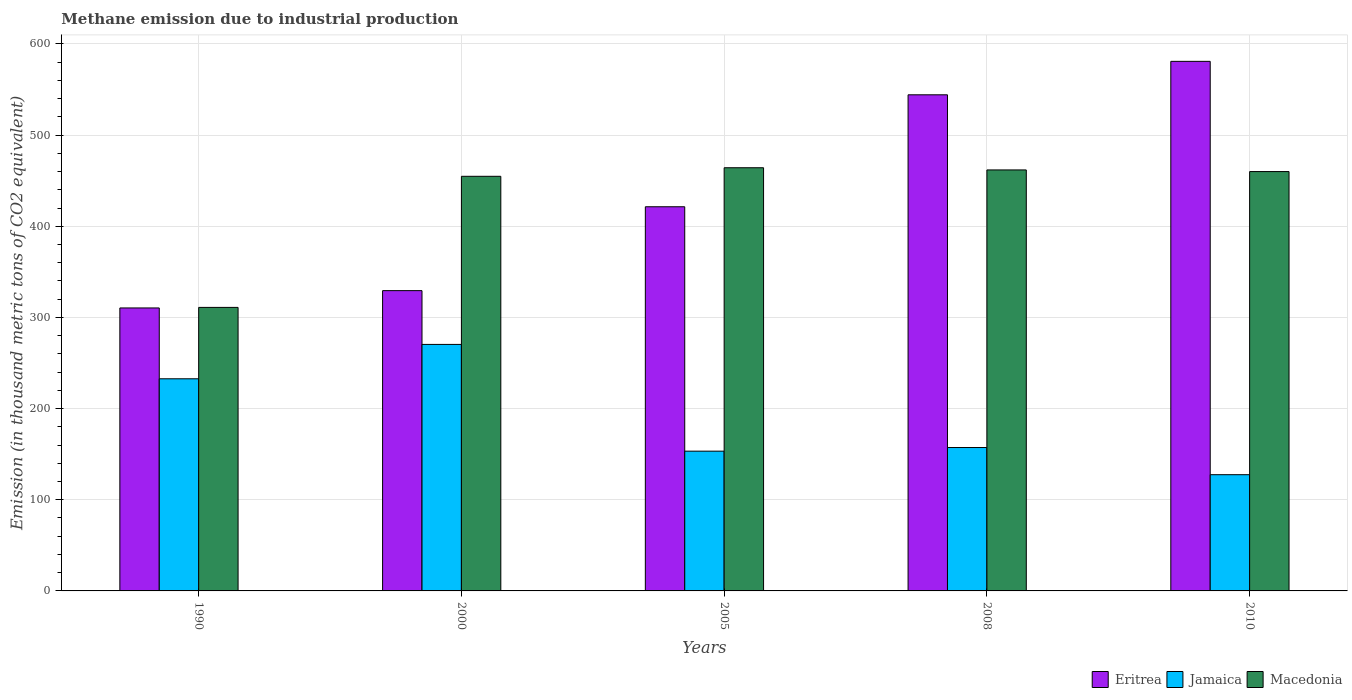How many groups of bars are there?
Provide a short and direct response. 5. Are the number of bars per tick equal to the number of legend labels?
Offer a terse response. Yes. How many bars are there on the 1st tick from the left?
Provide a succinct answer. 3. What is the label of the 4th group of bars from the left?
Ensure brevity in your answer.  2008. What is the amount of methane emitted in Macedonia in 2000?
Your answer should be very brief. 454.8. Across all years, what is the maximum amount of methane emitted in Eritrea?
Offer a very short reply. 580.9. Across all years, what is the minimum amount of methane emitted in Eritrea?
Your response must be concise. 310.4. In which year was the amount of methane emitted in Macedonia maximum?
Your answer should be very brief. 2005. In which year was the amount of methane emitted in Eritrea minimum?
Offer a very short reply. 1990. What is the total amount of methane emitted in Eritrea in the graph?
Offer a very short reply. 2186.3. What is the difference between the amount of methane emitted in Eritrea in 2005 and that in 2010?
Offer a terse response. -159.5. What is the difference between the amount of methane emitted in Eritrea in 2005 and the amount of methane emitted in Macedonia in 1990?
Make the answer very short. 110.4. What is the average amount of methane emitted in Eritrea per year?
Ensure brevity in your answer.  437.26. In the year 2005, what is the difference between the amount of methane emitted in Eritrea and amount of methane emitted in Macedonia?
Your response must be concise. -42.8. In how many years, is the amount of methane emitted in Macedonia greater than 560 thousand metric tons?
Provide a succinct answer. 0. What is the ratio of the amount of methane emitted in Jamaica in 2008 to that in 2010?
Your response must be concise. 1.23. Is the difference between the amount of methane emitted in Eritrea in 2008 and 2010 greater than the difference between the amount of methane emitted in Macedonia in 2008 and 2010?
Keep it short and to the point. No. What is the difference between the highest and the second highest amount of methane emitted in Macedonia?
Ensure brevity in your answer.  2.4. What is the difference between the highest and the lowest amount of methane emitted in Macedonia?
Make the answer very short. 153.2. What does the 2nd bar from the left in 2010 represents?
Offer a very short reply. Jamaica. What does the 1st bar from the right in 2000 represents?
Offer a very short reply. Macedonia. How many bars are there?
Ensure brevity in your answer.  15. Are all the bars in the graph horizontal?
Ensure brevity in your answer.  No. Does the graph contain grids?
Your answer should be very brief. Yes. Where does the legend appear in the graph?
Provide a short and direct response. Bottom right. What is the title of the graph?
Keep it short and to the point. Methane emission due to industrial production. What is the label or title of the Y-axis?
Provide a short and direct response. Emission (in thousand metric tons of CO2 equivalent). What is the Emission (in thousand metric tons of CO2 equivalent) in Eritrea in 1990?
Offer a terse response. 310.4. What is the Emission (in thousand metric tons of CO2 equivalent) in Jamaica in 1990?
Your answer should be compact. 232.7. What is the Emission (in thousand metric tons of CO2 equivalent) of Macedonia in 1990?
Offer a terse response. 311. What is the Emission (in thousand metric tons of CO2 equivalent) in Eritrea in 2000?
Make the answer very short. 329.4. What is the Emission (in thousand metric tons of CO2 equivalent) of Jamaica in 2000?
Give a very brief answer. 270.4. What is the Emission (in thousand metric tons of CO2 equivalent) of Macedonia in 2000?
Provide a succinct answer. 454.8. What is the Emission (in thousand metric tons of CO2 equivalent) of Eritrea in 2005?
Your answer should be very brief. 421.4. What is the Emission (in thousand metric tons of CO2 equivalent) of Jamaica in 2005?
Ensure brevity in your answer.  153.3. What is the Emission (in thousand metric tons of CO2 equivalent) in Macedonia in 2005?
Provide a succinct answer. 464.2. What is the Emission (in thousand metric tons of CO2 equivalent) in Eritrea in 2008?
Your answer should be compact. 544.2. What is the Emission (in thousand metric tons of CO2 equivalent) in Jamaica in 2008?
Ensure brevity in your answer.  157.3. What is the Emission (in thousand metric tons of CO2 equivalent) of Macedonia in 2008?
Your answer should be very brief. 461.8. What is the Emission (in thousand metric tons of CO2 equivalent) of Eritrea in 2010?
Ensure brevity in your answer.  580.9. What is the Emission (in thousand metric tons of CO2 equivalent) of Jamaica in 2010?
Provide a short and direct response. 127.5. What is the Emission (in thousand metric tons of CO2 equivalent) of Macedonia in 2010?
Provide a short and direct response. 460. Across all years, what is the maximum Emission (in thousand metric tons of CO2 equivalent) in Eritrea?
Keep it short and to the point. 580.9. Across all years, what is the maximum Emission (in thousand metric tons of CO2 equivalent) in Jamaica?
Your response must be concise. 270.4. Across all years, what is the maximum Emission (in thousand metric tons of CO2 equivalent) in Macedonia?
Provide a short and direct response. 464.2. Across all years, what is the minimum Emission (in thousand metric tons of CO2 equivalent) of Eritrea?
Your response must be concise. 310.4. Across all years, what is the minimum Emission (in thousand metric tons of CO2 equivalent) of Jamaica?
Offer a terse response. 127.5. Across all years, what is the minimum Emission (in thousand metric tons of CO2 equivalent) in Macedonia?
Your answer should be very brief. 311. What is the total Emission (in thousand metric tons of CO2 equivalent) in Eritrea in the graph?
Give a very brief answer. 2186.3. What is the total Emission (in thousand metric tons of CO2 equivalent) in Jamaica in the graph?
Make the answer very short. 941.2. What is the total Emission (in thousand metric tons of CO2 equivalent) in Macedonia in the graph?
Provide a short and direct response. 2151.8. What is the difference between the Emission (in thousand metric tons of CO2 equivalent) in Eritrea in 1990 and that in 2000?
Make the answer very short. -19. What is the difference between the Emission (in thousand metric tons of CO2 equivalent) of Jamaica in 1990 and that in 2000?
Offer a very short reply. -37.7. What is the difference between the Emission (in thousand metric tons of CO2 equivalent) of Macedonia in 1990 and that in 2000?
Your response must be concise. -143.8. What is the difference between the Emission (in thousand metric tons of CO2 equivalent) of Eritrea in 1990 and that in 2005?
Make the answer very short. -111. What is the difference between the Emission (in thousand metric tons of CO2 equivalent) in Jamaica in 1990 and that in 2005?
Offer a very short reply. 79.4. What is the difference between the Emission (in thousand metric tons of CO2 equivalent) in Macedonia in 1990 and that in 2005?
Offer a very short reply. -153.2. What is the difference between the Emission (in thousand metric tons of CO2 equivalent) of Eritrea in 1990 and that in 2008?
Provide a succinct answer. -233.8. What is the difference between the Emission (in thousand metric tons of CO2 equivalent) of Jamaica in 1990 and that in 2008?
Provide a succinct answer. 75.4. What is the difference between the Emission (in thousand metric tons of CO2 equivalent) of Macedonia in 1990 and that in 2008?
Your answer should be compact. -150.8. What is the difference between the Emission (in thousand metric tons of CO2 equivalent) of Eritrea in 1990 and that in 2010?
Make the answer very short. -270.5. What is the difference between the Emission (in thousand metric tons of CO2 equivalent) in Jamaica in 1990 and that in 2010?
Your answer should be compact. 105.2. What is the difference between the Emission (in thousand metric tons of CO2 equivalent) in Macedonia in 1990 and that in 2010?
Ensure brevity in your answer.  -149. What is the difference between the Emission (in thousand metric tons of CO2 equivalent) of Eritrea in 2000 and that in 2005?
Provide a short and direct response. -92. What is the difference between the Emission (in thousand metric tons of CO2 equivalent) in Jamaica in 2000 and that in 2005?
Your answer should be compact. 117.1. What is the difference between the Emission (in thousand metric tons of CO2 equivalent) of Macedonia in 2000 and that in 2005?
Your response must be concise. -9.4. What is the difference between the Emission (in thousand metric tons of CO2 equivalent) of Eritrea in 2000 and that in 2008?
Your answer should be compact. -214.8. What is the difference between the Emission (in thousand metric tons of CO2 equivalent) in Jamaica in 2000 and that in 2008?
Provide a short and direct response. 113.1. What is the difference between the Emission (in thousand metric tons of CO2 equivalent) in Eritrea in 2000 and that in 2010?
Ensure brevity in your answer.  -251.5. What is the difference between the Emission (in thousand metric tons of CO2 equivalent) in Jamaica in 2000 and that in 2010?
Provide a short and direct response. 142.9. What is the difference between the Emission (in thousand metric tons of CO2 equivalent) of Eritrea in 2005 and that in 2008?
Your response must be concise. -122.8. What is the difference between the Emission (in thousand metric tons of CO2 equivalent) of Jamaica in 2005 and that in 2008?
Your answer should be compact. -4. What is the difference between the Emission (in thousand metric tons of CO2 equivalent) in Macedonia in 2005 and that in 2008?
Keep it short and to the point. 2.4. What is the difference between the Emission (in thousand metric tons of CO2 equivalent) in Eritrea in 2005 and that in 2010?
Offer a terse response. -159.5. What is the difference between the Emission (in thousand metric tons of CO2 equivalent) of Jamaica in 2005 and that in 2010?
Provide a succinct answer. 25.8. What is the difference between the Emission (in thousand metric tons of CO2 equivalent) in Eritrea in 2008 and that in 2010?
Offer a terse response. -36.7. What is the difference between the Emission (in thousand metric tons of CO2 equivalent) in Jamaica in 2008 and that in 2010?
Offer a very short reply. 29.8. What is the difference between the Emission (in thousand metric tons of CO2 equivalent) in Eritrea in 1990 and the Emission (in thousand metric tons of CO2 equivalent) in Jamaica in 2000?
Make the answer very short. 40. What is the difference between the Emission (in thousand metric tons of CO2 equivalent) of Eritrea in 1990 and the Emission (in thousand metric tons of CO2 equivalent) of Macedonia in 2000?
Make the answer very short. -144.4. What is the difference between the Emission (in thousand metric tons of CO2 equivalent) of Jamaica in 1990 and the Emission (in thousand metric tons of CO2 equivalent) of Macedonia in 2000?
Your answer should be compact. -222.1. What is the difference between the Emission (in thousand metric tons of CO2 equivalent) in Eritrea in 1990 and the Emission (in thousand metric tons of CO2 equivalent) in Jamaica in 2005?
Offer a terse response. 157.1. What is the difference between the Emission (in thousand metric tons of CO2 equivalent) of Eritrea in 1990 and the Emission (in thousand metric tons of CO2 equivalent) of Macedonia in 2005?
Ensure brevity in your answer.  -153.8. What is the difference between the Emission (in thousand metric tons of CO2 equivalent) in Jamaica in 1990 and the Emission (in thousand metric tons of CO2 equivalent) in Macedonia in 2005?
Your response must be concise. -231.5. What is the difference between the Emission (in thousand metric tons of CO2 equivalent) of Eritrea in 1990 and the Emission (in thousand metric tons of CO2 equivalent) of Jamaica in 2008?
Your response must be concise. 153.1. What is the difference between the Emission (in thousand metric tons of CO2 equivalent) in Eritrea in 1990 and the Emission (in thousand metric tons of CO2 equivalent) in Macedonia in 2008?
Ensure brevity in your answer.  -151.4. What is the difference between the Emission (in thousand metric tons of CO2 equivalent) in Jamaica in 1990 and the Emission (in thousand metric tons of CO2 equivalent) in Macedonia in 2008?
Offer a very short reply. -229.1. What is the difference between the Emission (in thousand metric tons of CO2 equivalent) of Eritrea in 1990 and the Emission (in thousand metric tons of CO2 equivalent) of Jamaica in 2010?
Provide a succinct answer. 182.9. What is the difference between the Emission (in thousand metric tons of CO2 equivalent) of Eritrea in 1990 and the Emission (in thousand metric tons of CO2 equivalent) of Macedonia in 2010?
Give a very brief answer. -149.6. What is the difference between the Emission (in thousand metric tons of CO2 equivalent) in Jamaica in 1990 and the Emission (in thousand metric tons of CO2 equivalent) in Macedonia in 2010?
Your answer should be very brief. -227.3. What is the difference between the Emission (in thousand metric tons of CO2 equivalent) of Eritrea in 2000 and the Emission (in thousand metric tons of CO2 equivalent) of Jamaica in 2005?
Provide a short and direct response. 176.1. What is the difference between the Emission (in thousand metric tons of CO2 equivalent) in Eritrea in 2000 and the Emission (in thousand metric tons of CO2 equivalent) in Macedonia in 2005?
Offer a terse response. -134.8. What is the difference between the Emission (in thousand metric tons of CO2 equivalent) of Jamaica in 2000 and the Emission (in thousand metric tons of CO2 equivalent) of Macedonia in 2005?
Offer a very short reply. -193.8. What is the difference between the Emission (in thousand metric tons of CO2 equivalent) of Eritrea in 2000 and the Emission (in thousand metric tons of CO2 equivalent) of Jamaica in 2008?
Your response must be concise. 172.1. What is the difference between the Emission (in thousand metric tons of CO2 equivalent) in Eritrea in 2000 and the Emission (in thousand metric tons of CO2 equivalent) in Macedonia in 2008?
Provide a succinct answer. -132.4. What is the difference between the Emission (in thousand metric tons of CO2 equivalent) of Jamaica in 2000 and the Emission (in thousand metric tons of CO2 equivalent) of Macedonia in 2008?
Offer a terse response. -191.4. What is the difference between the Emission (in thousand metric tons of CO2 equivalent) of Eritrea in 2000 and the Emission (in thousand metric tons of CO2 equivalent) of Jamaica in 2010?
Your response must be concise. 201.9. What is the difference between the Emission (in thousand metric tons of CO2 equivalent) of Eritrea in 2000 and the Emission (in thousand metric tons of CO2 equivalent) of Macedonia in 2010?
Provide a succinct answer. -130.6. What is the difference between the Emission (in thousand metric tons of CO2 equivalent) in Jamaica in 2000 and the Emission (in thousand metric tons of CO2 equivalent) in Macedonia in 2010?
Keep it short and to the point. -189.6. What is the difference between the Emission (in thousand metric tons of CO2 equivalent) of Eritrea in 2005 and the Emission (in thousand metric tons of CO2 equivalent) of Jamaica in 2008?
Give a very brief answer. 264.1. What is the difference between the Emission (in thousand metric tons of CO2 equivalent) of Eritrea in 2005 and the Emission (in thousand metric tons of CO2 equivalent) of Macedonia in 2008?
Your answer should be compact. -40.4. What is the difference between the Emission (in thousand metric tons of CO2 equivalent) in Jamaica in 2005 and the Emission (in thousand metric tons of CO2 equivalent) in Macedonia in 2008?
Offer a terse response. -308.5. What is the difference between the Emission (in thousand metric tons of CO2 equivalent) of Eritrea in 2005 and the Emission (in thousand metric tons of CO2 equivalent) of Jamaica in 2010?
Keep it short and to the point. 293.9. What is the difference between the Emission (in thousand metric tons of CO2 equivalent) of Eritrea in 2005 and the Emission (in thousand metric tons of CO2 equivalent) of Macedonia in 2010?
Provide a short and direct response. -38.6. What is the difference between the Emission (in thousand metric tons of CO2 equivalent) in Jamaica in 2005 and the Emission (in thousand metric tons of CO2 equivalent) in Macedonia in 2010?
Keep it short and to the point. -306.7. What is the difference between the Emission (in thousand metric tons of CO2 equivalent) in Eritrea in 2008 and the Emission (in thousand metric tons of CO2 equivalent) in Jamaica in 2010?
Ensure brevity in your answer.  416.7. What is the difference between the Emission (in thousand metric tons of CO2 equivalent) in Eritrea in 2008 and the Emission (in thousand metric tons of CO2 equivalent) in Macedonia in 2010?
Ensure brevity in your answer.  84.2. What is the difference between the Emission (in thousand metric tons of CO2 equivalent) in Jamaica in 2008 and the Emission (in thousand metric tons of CO2 equivalent) in Macedonia in 2010?
Keep it short and to the point. -302.7. What is the average Emission (in thousand metric tons of CO2 equivalent) in Eritrea per year?
Your answer should be compact. 437.26. What is the average Emission (in thousand metric tons of CO2 equivalent) of Jamaica per year?
Your answer should be compact. 188.24. What is the average Emission (in thousand metric tons of CO2 equivalent) of Macedonia per year?
Give a very brief answer. 430.36. In the year 1990, what is the difference between the Emission (in thousand metric tons of CO2 equivalent) in Eritrea and Emission (in thousand metric tons of CO2 equivalent) in Jamaica?
Make the answer very short. 77.7. In the year 1990, what is the difference between the Emission (in thousand metric tons of CO2 equivalent) in Eritrea and Emission (in thousand metric tons of CO2 equivalent) in Macedonia?
Provide a short and direct response. -0.6. In the year 1990, what is the difference between the Emission (in thousand metric tons of CO2 equivalent) in Jamaica and Emission (in thousand metric tons of CO2 equivalent) in Macedonia?
Keep it short and to the point. -78.3. In the year 2000, what is the difference between the Emission (in thousand metric tons of CO2 equivalent) of Eritrea and Emission (in thousand metric tons of CO2 equivalent) of Macedonia?
Provide a short and direct response. -125.4. In the year 2000, what is the difference between the Emission (in thousand metric tons of CO2 equivalent) of Jamaica and Emission (in thousand metric tons of CO2 equivalent) of Macedonia?
Offer a terse response. -184.4. In the year 2005, what is the difference between the Emission (in thousand metric tons of CO2 equivalent) of Eritrea and Emission (in thousand metric tons of CO2 equivalent) of Jamaica?
Provide a succinct answer. 268.1. In the year 2005, what is the difference between the Emission (in thousand metric tons of CO2 equivalent) in Eritrea and Emission (in thousand metric tons of CO2 equivalent) in Macedonia?
Provide a short and direct response. -42.8. In the year 2005, what is the difference between the Emission (in thousand metric tons of CO2 equivalent) in Jamaica and Emission (in thousand metric tons of CO2 equivalent) in Macedonia?
Your answer should be compact. -310.9. In the year 2008, what is the difference between the Emission (in thousand metric tons of CO2 equivalent) in Eritrea and Emission (in thousand metric tons of CO2 equivalent) in Jamaica?
Your answer should be very brief. 386.9. In the year 2008, what is the difference between the Emission (in thousand metric tons of CO2 equivalent) in Eritrea and Emission (in thousand metric tons of CO2 equivalent) in Macedonia?
Provide a succinct answer. 82.4. In the year 2008, what is the difference between the Emission (in thousand metric tons of CO2 equivalent) in Jamaica and Emission (in thousand metric tons of CO2 equivalent) in Macedonia?
Your response must be concise. -304.5. In the year 2010, what is the difference between the Emission (in thousand metric tons of CO2 equivalent) in Eritrea and Emission (in thousand metric tons of CO2 equivalent) in Jamaica?
Give a very brief answer. 453.4. In the year 2010, what is the difference between the Emission (in thousand metric tons of CO2 equivalent) in Eritrea and Emission (in thousand metric tons of CO2 equivalent) in Macedonia?
Your response must be concise. 120.9. In the year 2010, what is the difference between the Emission (in thousand metric tons of CO2 equivalent) in Jamaica and Emission (in thousand metric tons of CO2 equivalent) in Macedonia?
Your response must be concise. -332.5. What is the ratio of the Emission (in thousand metric tons of CO2 equivalent) in Eritrea in 1990 to that in 2000?
Offer a terse response. 0.94. What is the ratio of the Emission (in thousand metric tons of CO2 equivalent) of Jamaica in 1990 to that in 2000?
Provide a short and direct response. 0.86. What is the ratio of the Emission (in thousand metric tons of CO2 equivalent) of Macedonia in 1990 to that in 2000?
Give a very brief answer. 0.68. What is the ratio of the Emission (in thousand metric tons of CO2 equivalent) of Eritrea in 1990 to that in 2005?
Provide a succinct answer. 0.74. What is the ratio of the Emission (in thousand metric tons of CO2 equivalent) of Jamaica in 1990 to that in 2005?
Keep it short and to the point. 1.52. What is the ratio of the Emission (in thousand metric tons of CO2 equivalent) of Macedonia in 1990 to that in 2005?
Ensure brevity in your answer.  0.67. What is the ratio of the Emission (in thousand metric tons of CO2 equivalent) in Eritrea in 1990 to that in 2008?
Give a very brief answer. 0.57. What is the ratio of the Emission (in thousand metric tons of CO2 equivalent) in Jamaica in 1990 to that in 2008?
Offer a terse response. 1.48. What is the ratio of the Emission (in thousand metric tons of CO2 equivalent) in Macedonia in 1990 to that in 2008?
Ensure brevity in your answer.  0.67. What is the ratio of the Emission (in thousand metric tons of CO2 equivalent) of Eritrea in 1990 to that in 2010?
Provide a succinct answer. 0.53. What is the ratio of the Emission (in thousand metric tons of CO2 equivalent) of Jamaica in 1990 to that in 2010?
Offer a very short reply. 1.83. What is the ratio of the Emission (in thousand metric tons of CO2 equivalent) of Macedonia in 1990 to that in 2010?
Offer a very short reply. 0.68. What is the ratio of the Emission (in thousand metric tons of CO2 equivalent) in Eritrea in 2000 to that in 2005?
Give a very brief answer. 0.78. What is the ratio of the Emission (in thousand metric tons of CO2 equivalent) in Jamaica in 2000 to that in 2005?
Give a very brief answer. 1.76. What is the ratio of the Emission (in thousand metric tons of CO2 equivalent) in Macedonia in 2000 to that in 2005?
Provide a short and direct response. 0.98. What is the ratio of the Emission (in thousand metric tons of CO2 equivalent) of Eritrea in 2000 to that in 2008?
Offer a terse response. 0.61. What is the ratio of the Emission (in thousand metric tons of CO2 equivalent) of Jamaica in 2000 to that in 2008?
Provide a short and direct response. 1.72. What is the ratio of the Emission (in thousand metric tons of CO2 equivalent) in Eritrea in 2000 to that in 2010?
Provide a short and direct response. 0.57. What is the ratio of the Emission (in thousand metric tons of CO2 equivalent) of Jamaica in 2000 to that in 2010?
Ensure brevity in your answer.  2.12. What is the ratio of the Emission (in thousand metric tons of CO2 equivalent) of Macedonia in 2000 to that in 2010?
Your answer should be very brief. 0.99. What is the ratio of the Emission (in thousand metric tons of CO2 equivalent) of Eritrea in 2005 to that in 2008?
Your answer should be compact. 0.77. What is the ratio of the Emission (in thousand metric tons of CO2 equivalent) in Jamaica in 2005 to that in 2008?
Provide a short and direct response. 0.97. What is the ratio of the Emission (in thousand metric tons of CO2 equivalent) in Macedonia in 2005 to that in 2008?
Give a very brief answer. 1.01. What is the ratio of the Emission (in thousand metric tons of CO2 equivalent) in Eritrea in 2005 to that in 2010?
Make the answer very short. 0.73. What is the ratio of the Emission (in thousand metric tons of CO2 equivalent) in Jamaica in 2005 to that in 2010?
Your answer should be compact. 1.2. What is the ratio of the Emission (in thousand metric tons of CO2 equivalent) of Macedonia in 2005 to that in 2010?
Offer a terse response. 1.01. What is the ratio of the Emission (in thousand metric tons of CO2 equivalent) of Eritrea in 2008 to that in 2010?
Provide a succinct answer. 0.94. What is the ratio of the Emission (in thousand metric tons of CO2 equivalent) in Jamaica in 2008 to that in 2010?
Provide a succinct answer. 1.23. What is the difference between the highest and the second highest Emission (in thousand metric tons of CO2 equivalent) of Eritrea?
Your answer should be very brief. 36.7. What is the difference between the highest and the second highest Emission (in thousand metric tons of CO2 equivalent) of Jamaica?
Offer a very short reply. 37.7. What is the difference between the highest and the lowest Emission (in thousand metric tons of CO2 equivalent) of Eritrea?
Your response must be concise. 270.5. What is the difference between the highest and the lowest Emission (in thousand metric tons of CO2 equivalent) in Jamaica?
Give a very brief answer. 142.9. What is the difference between the highest and the lowest Emission (in thousand metric tons of CO2 equivalent) of Macedonia?
Give a very brief answer. 153.2. 